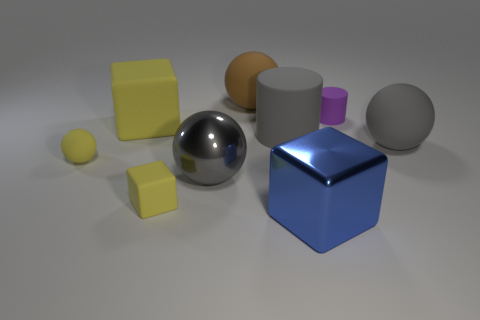The tiny matte object that is behind the yellow matte object that is behind the large matte cylinder is what shape?
Keep it short and to the point. Cylinder. What number of other things are there of the same shape as the big brown matte object?
Give a very brief answer. 3. What size is the matte cylinder that is left of the block right of the brown object?
Ensure brevity in your answer.  Large. Are any red metal objects visible?
Keep it short and to the point. No. There is a gray matte object that is on the left side of the tiny purple rubber thing; what number of purple matte cylinders are behind it?
Make the answer very short. 1. What is the shape of the gray rubber thing that is on the right side of the purple matte thing?
Offer a terse response. Sphere. What material is the small yellow object that is on the left side of the yellow thing that is behind the large gray object right of the blue block?
Ensure brevity in your answer.  Rubber. What number of other objects are the same size as the purple rubber cylinder?
Your response must be concise. 2. There is a blue object that is the same shape as the big yellow rubber thing; what is its material?
Ensure brevity in your answer.  Metal. The tiny sphere is what color?
Give a very brief answer. Yellow. 